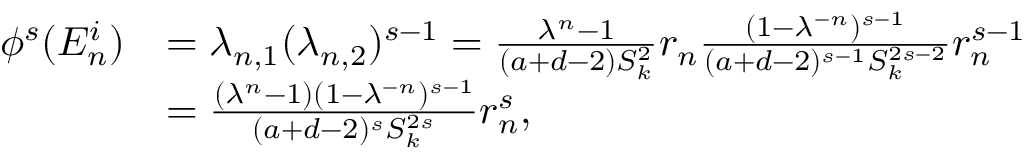<formula> <loc_0><loc_0><loc_500><loc_500>\begin{array} { r l } { \phi ^ { s } ( E _ { n } ^ { i } ) } & { = \lambda _ { n , 1 } ( \lambda _ { n , 2 } ) ^ { s - 1 } = \frac { \lambda ^ { n } - 1 } { ( a + d - 2 ) S _ { k } ^ { 2 } } r _ { n } \frac { ( 1 - \lambda ^ { - n } ) ^ { s - 1 } } { ( a + d - 2 ) ^ { s - 1 } S _ { k } ^ { 2 s - 2 } } r _ { n } ^ { s - 1 } } \\ & { = \frac { ( \lambda ^ { n } - 1 ) ( 1 - \lambda ^ { - n } ) ^ { s - 1 } } { ( a + d - 2 ) ^ { s } S _ { k } ^ { 2 s } } r _ { n } ^ { s } , } \end{array}</formula> 